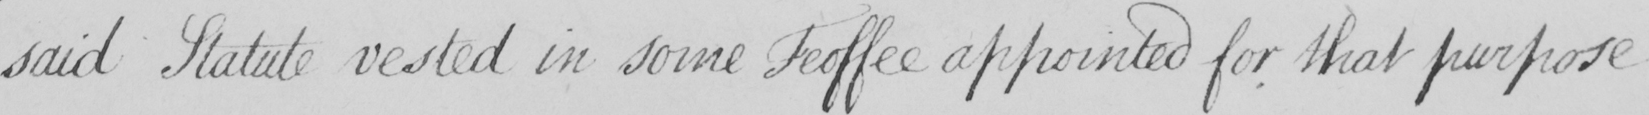Please transcribe the handwritten text in this image. said Statute vested in some Feoffee appointed for that purpose 